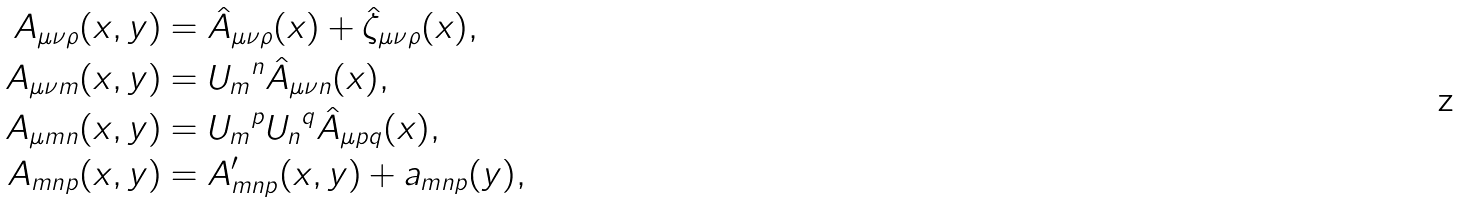<formula> <loc_0><loc_0><loc_500><loc_500>A _ { \mu \nu \rho } ( x , y ) & = \hat { A } _ { \mu \nu \rho } ( x ) + \hat { \zeta } _ { \mu \nu \rho } ( x ) , \\ A _ { \mu \nu m } ( x , y ) & = { U _ { m } } ^ { n } \hat { A } _ { \mu \nu n } ( x ) , \\ A _ { \mu m n } ( x , y ) & = { U _ { m } } ^ { p } { U _ { n } } ^ { q } \hat { A } _ { \mu p q } ( x ) , \\ A _ { m n p } ( x , y ) & = A ^ { \prime } _ { m n p } ( x , y ) + a _ { m n p } ( y ) ,</formula> 